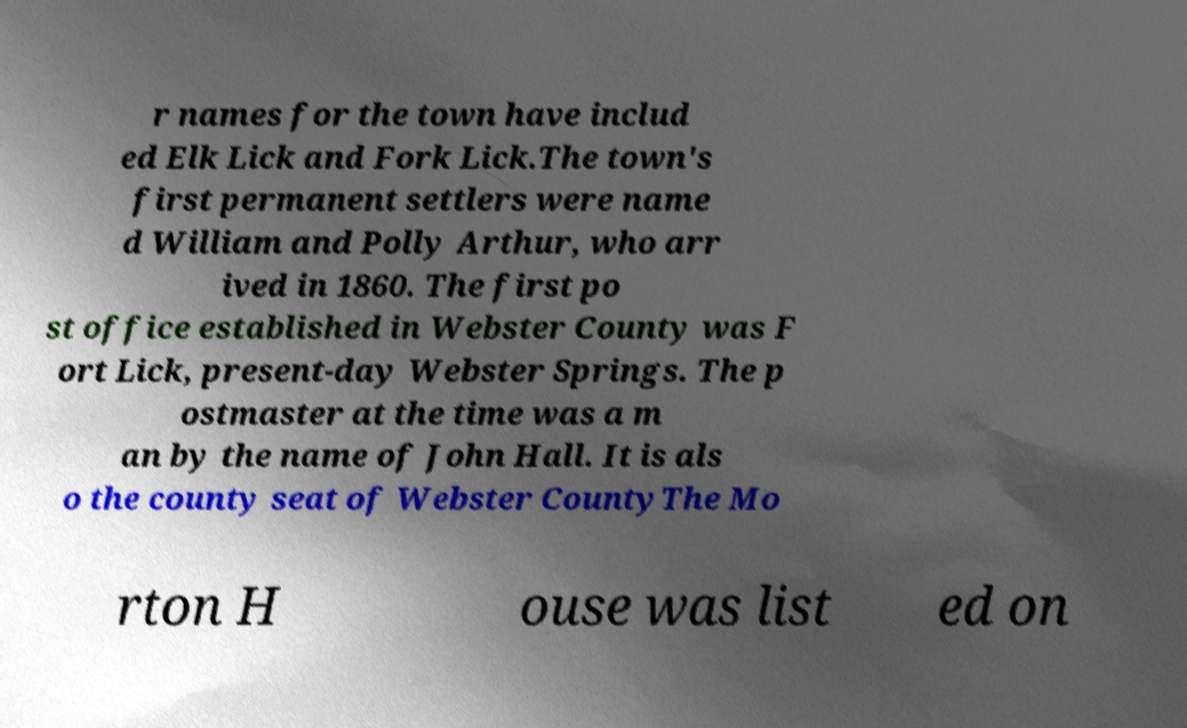Could you assist in decoding the text presented in this image and type it out clearly? r names for the town have includ ed Elk Lick and Fork Lick.The town's first permanent settlers were name d William and Polly Arthur, who arr ived in 1860. The first po st office established in Webster County was F ort Lick, present-day Webster Springs. The p ostmaster at the time was a m an by the name of John Hall. It is als o the county seat of Webster CountyThe Mo rton H ouse was list ed on 